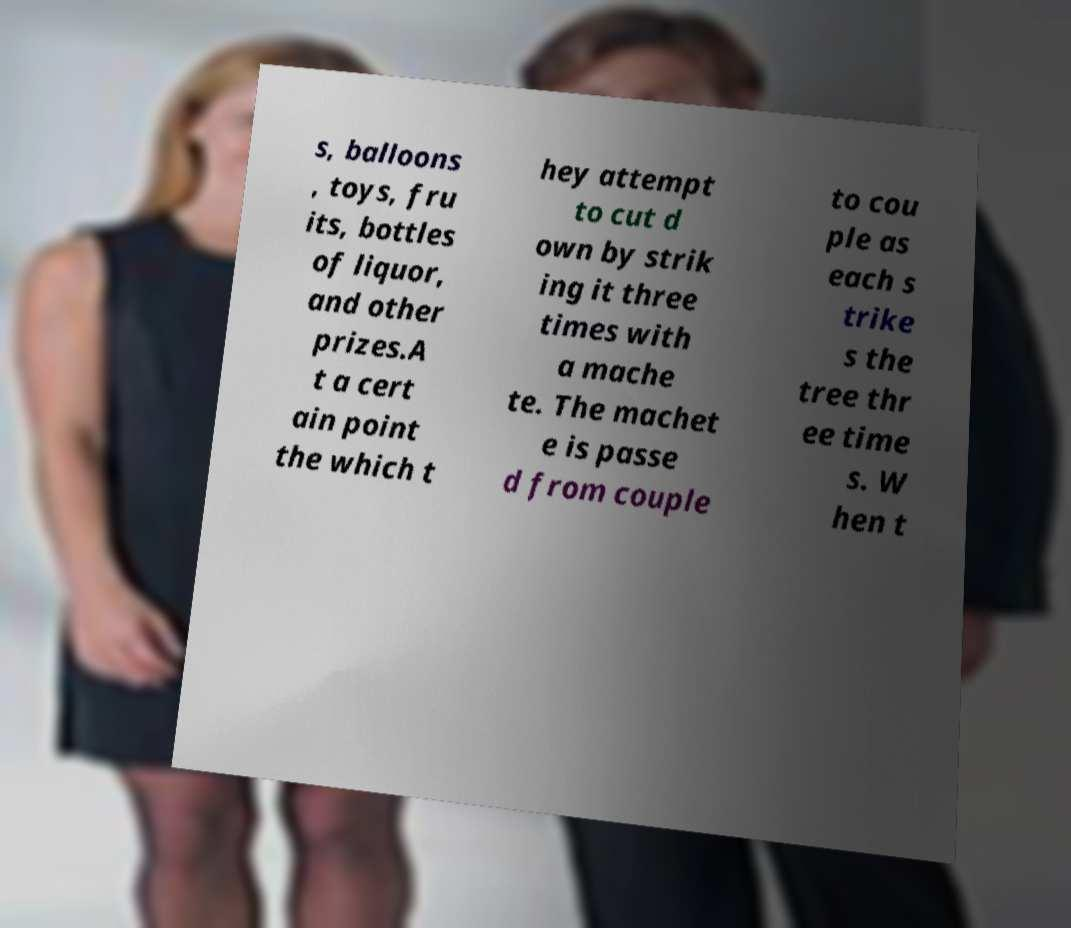Please read and relay the text visible in this image. What does it say? s, balloons , toys, fru its, bottles of liquor, and other prizes.A t a cert ain point the which t hey attempt to cut d own by strik ing it three times with a mache te. The machet e is passe d from couple to cou ple as each s trike s the tree thr ee time s. W hen t 